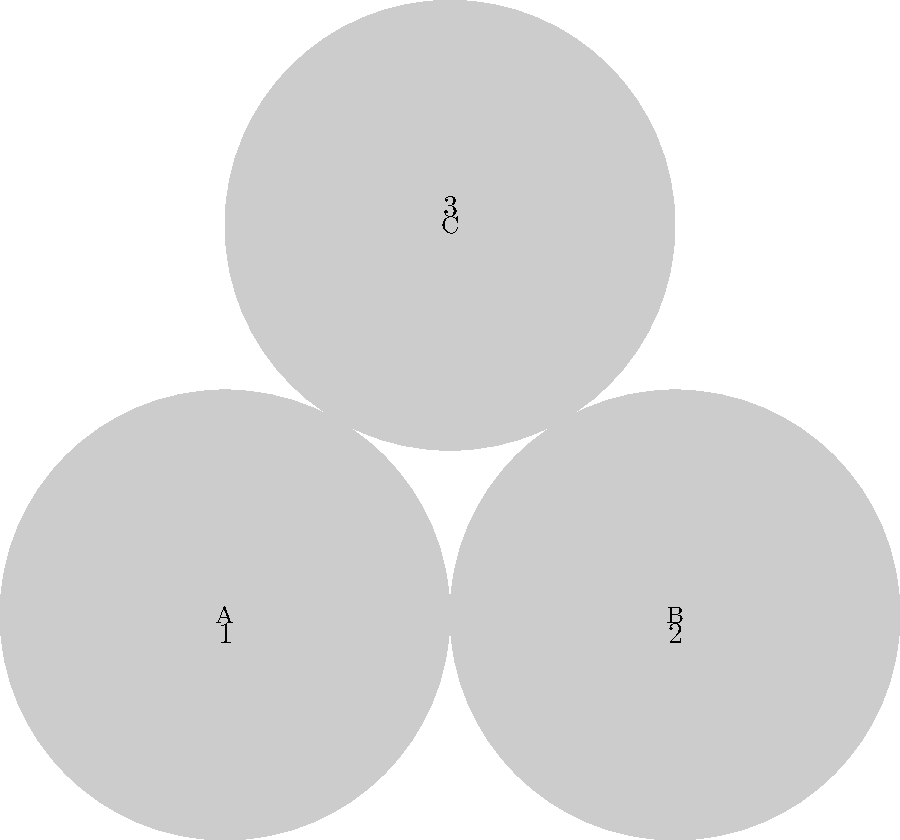Identify the key figures in the American Civil War represented by the portraits labeled 1, 2, and 3:

A) Abraham Lincoln
B) Jefferson Davis
C) Ulysses S. Grant

Match each number to the correct letter. To answer this question, we need to consider the roles and significance of each figure in the American Civil War:

1. Abraham Lincoln (A):
   - 16th President of the United States
   - Led the Union during the Civil War
   - Issued the Emancipation Proclamation
   - Known for his distinctive beard and top hat

2. Jefferson Davis (B):
   - President of the Confederate States of America
   - Led the Southern states during the Civil War
   - Former U.S. Senator from Mississippi
   - Known for his clean-shaven appearance

3. Ulysses S. Grant (C):
   - Commanding General of the Union Army
   - Led Union forces to victory in the Civil War
   - Later became the 18th President of the United States
   - Known for his full beard and military uniform

Based on these descriptions and the typical portrayal of these figures in historical images:

1 matches A (Abraham Lincoln)
2 matches B (Jefferson Davis)
3 matches C (Ulysses S. Grant)
Answer: 1-A, 2-B, 3-C 